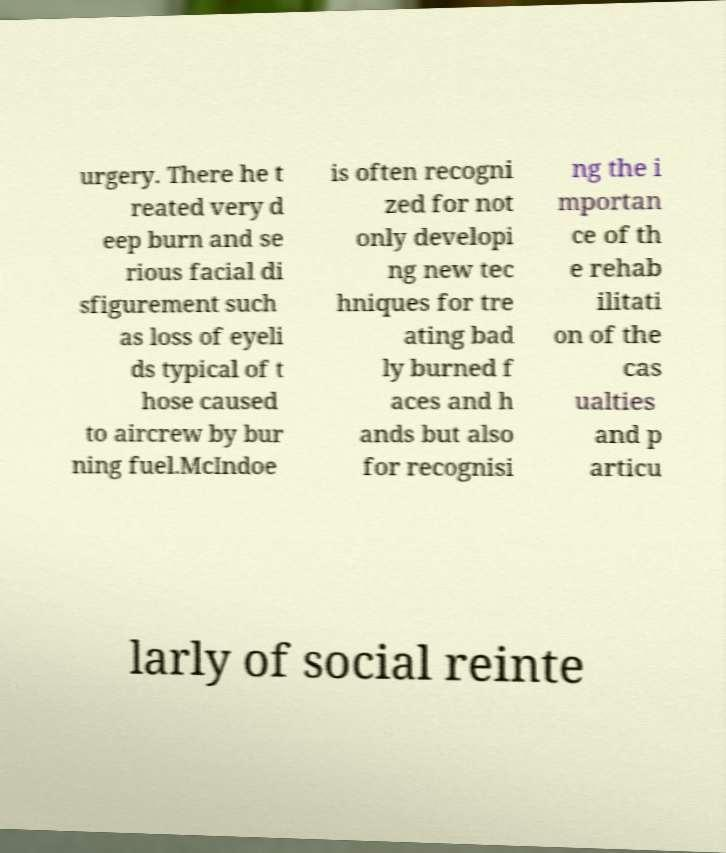Could you extract and type out the text from this image? urgery. There he t reated very d eep burn and se rious facial di sfigurement such as loss of eyeli ds typical of t hose caused to aircrew by bur ning fuel.McIndoe is often recogni zed for not only developi ng new tec hniques for tre ating bad ly burned f aces and h ands but also for recognisi ng the i mportan ce of th e rehab ilitati on of the cas ualties and p articu larly of social reinte 